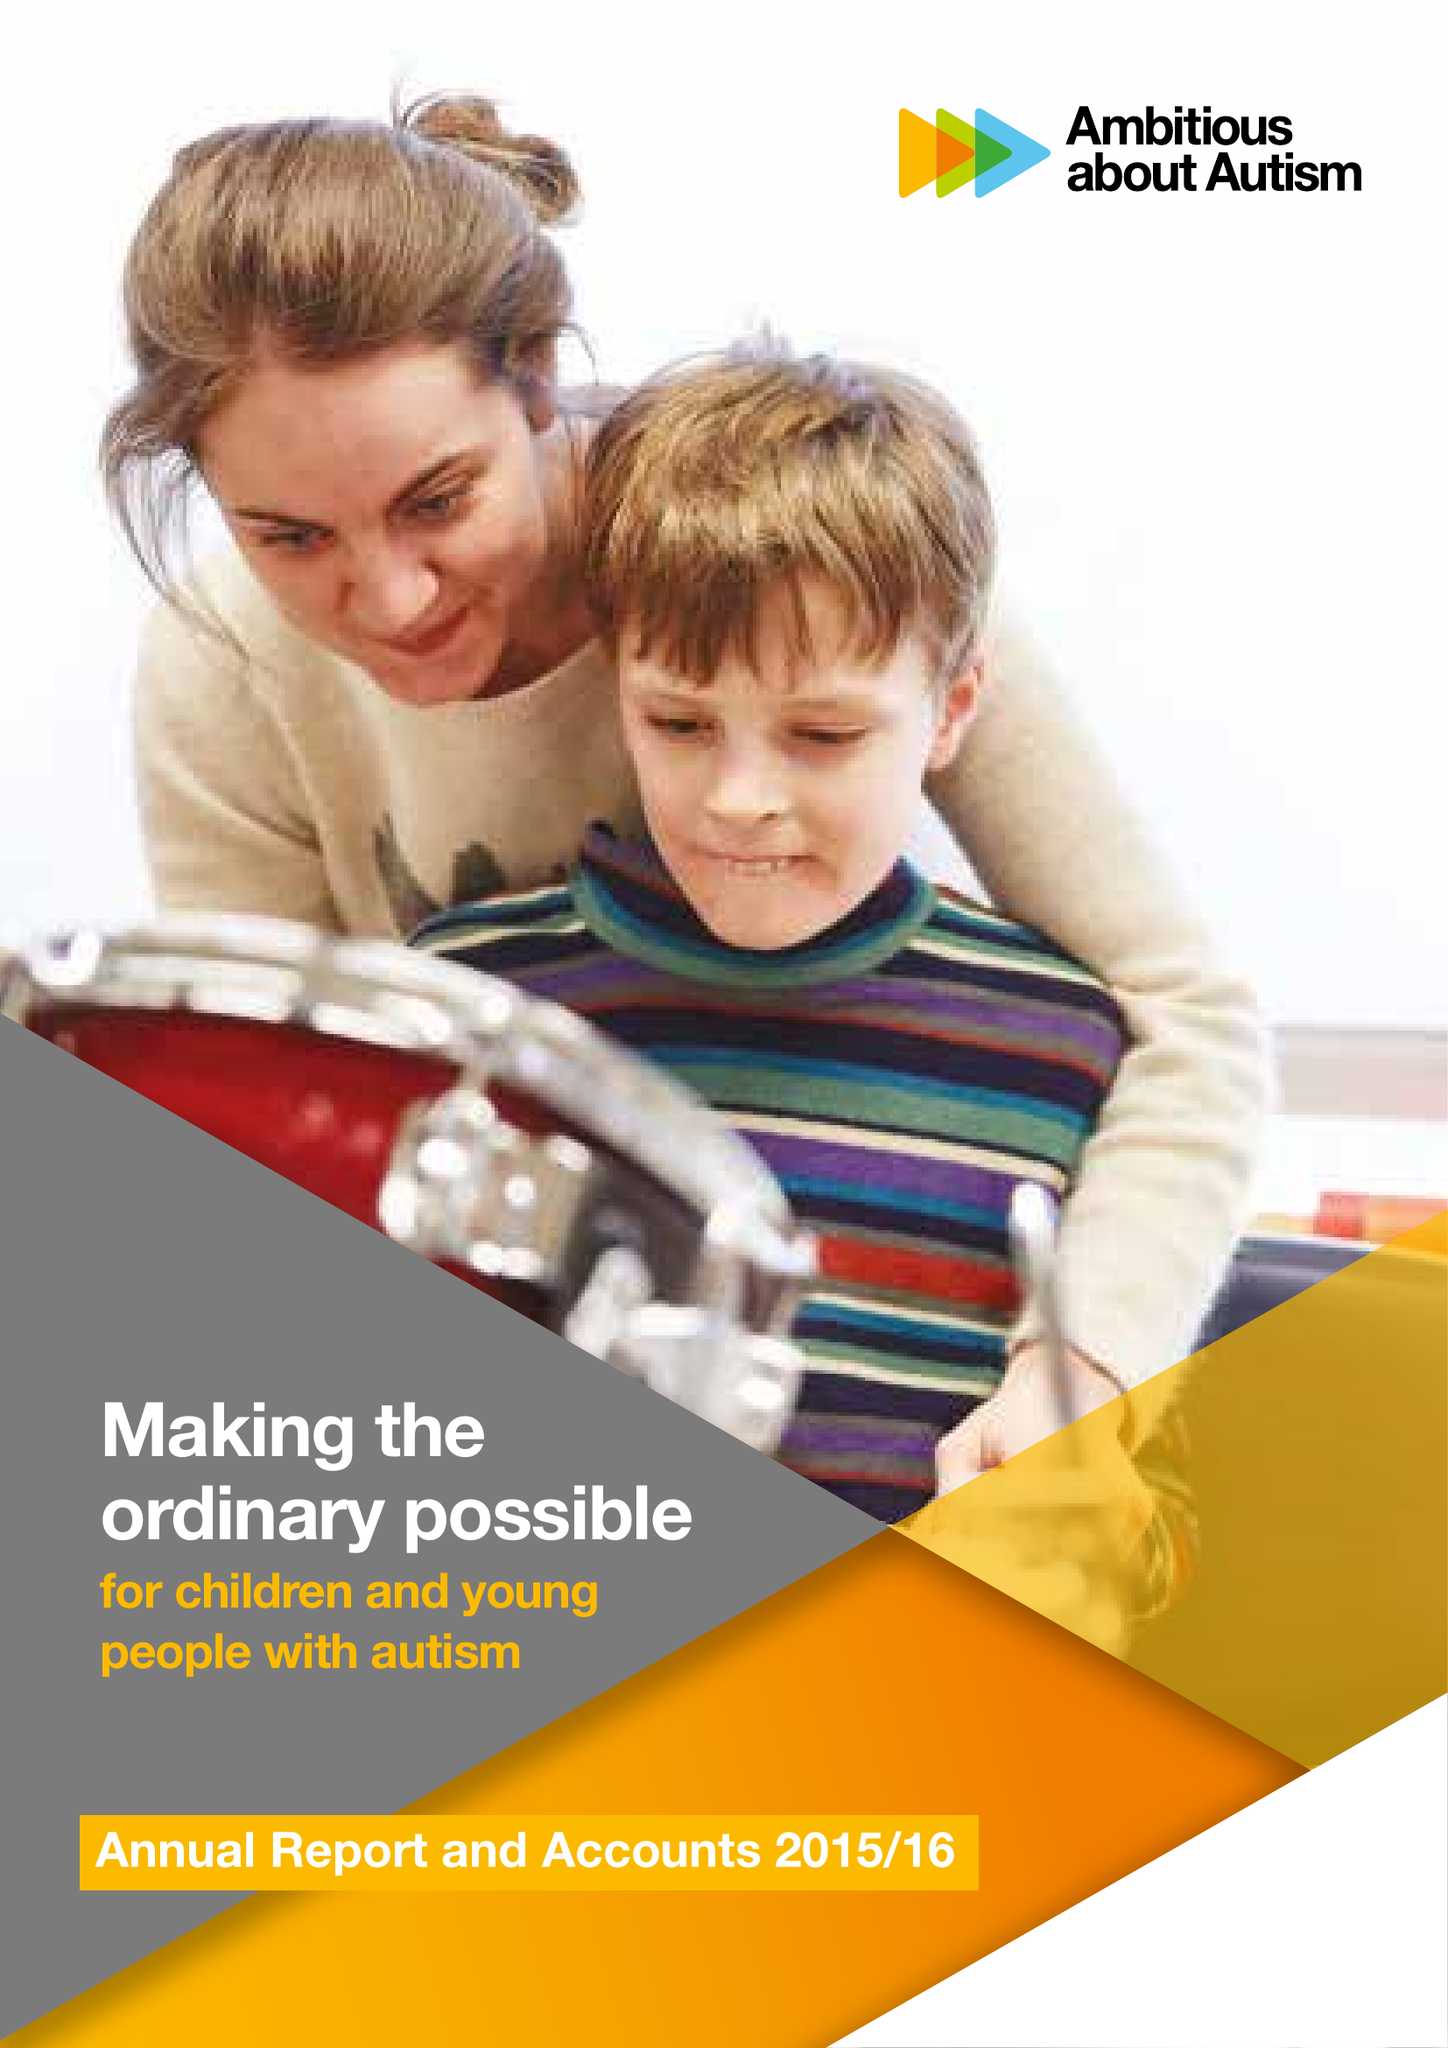What is the value for the address__postcode?
Answer the question using a single word or phrase. N10 3JA 